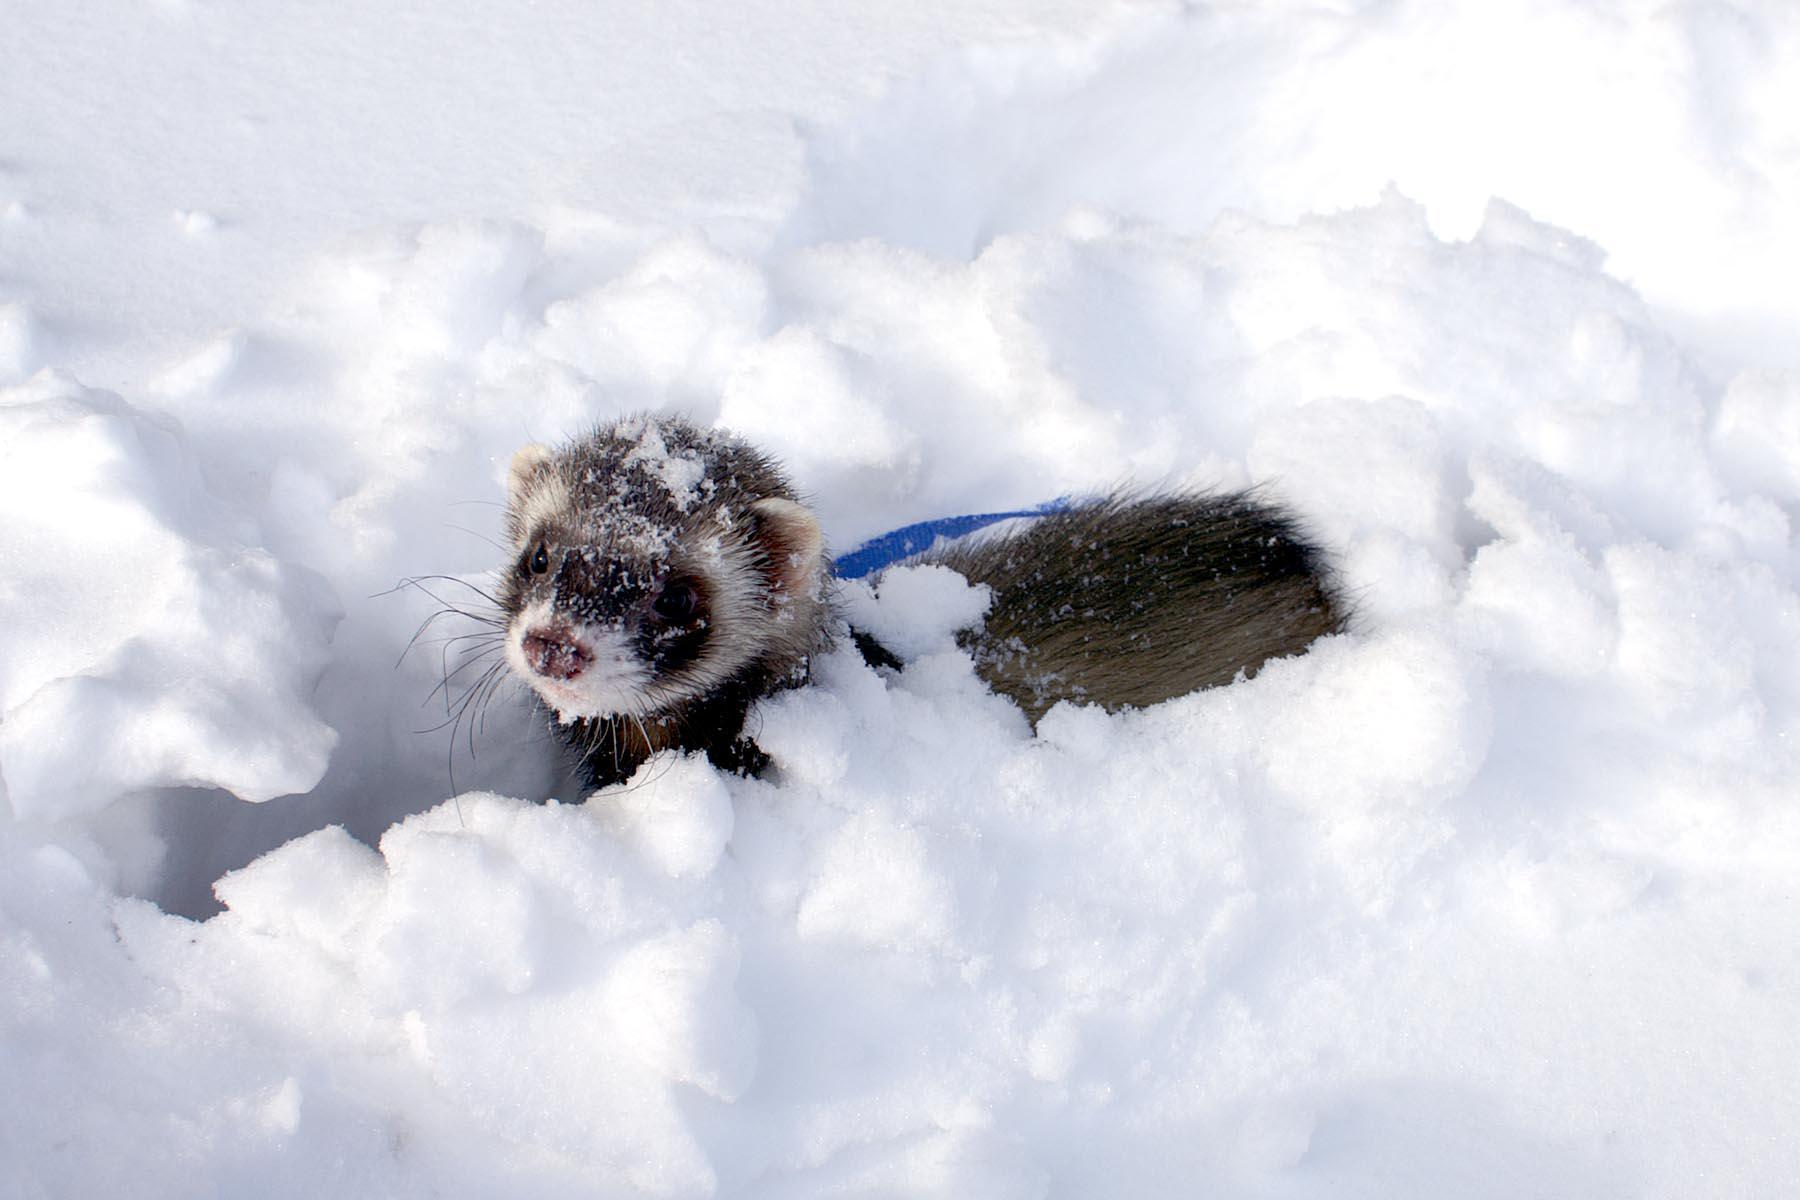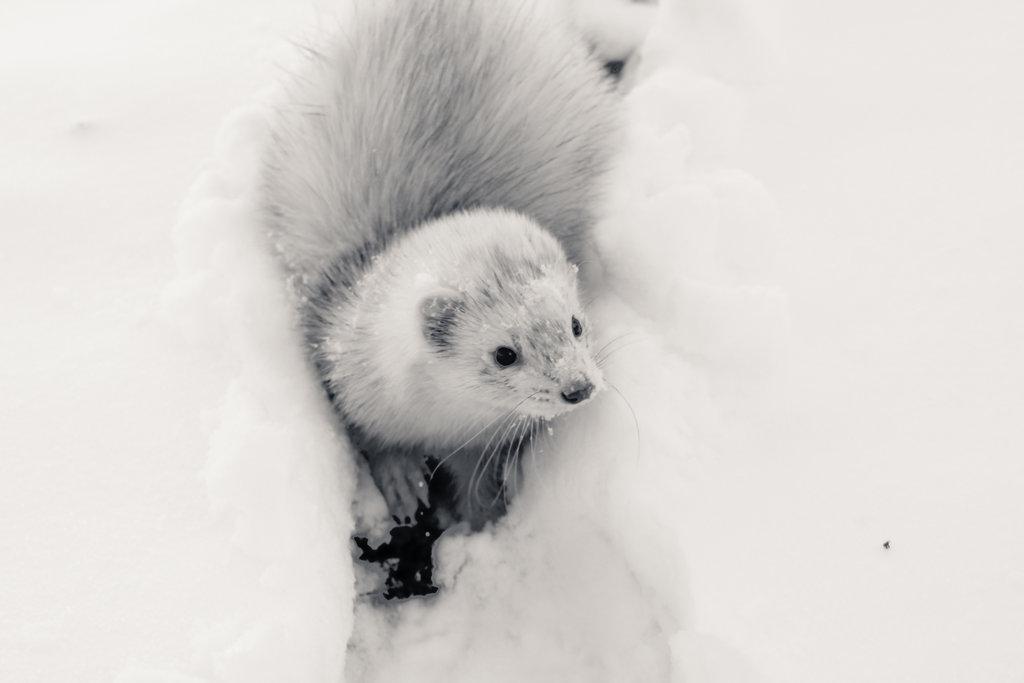The first image is the image on the left, the second image is the image on the right. For the images shown, is this caption "An image shows a ferret in a bowl of white fluff." true? Answer yes or no. No. The first image is the image on the left, the second image is the image on the right. Assess this claim about the two images: "The animal in the image on the left is outside in the snow.". Correct or not? Answer yes or no. Yes. 